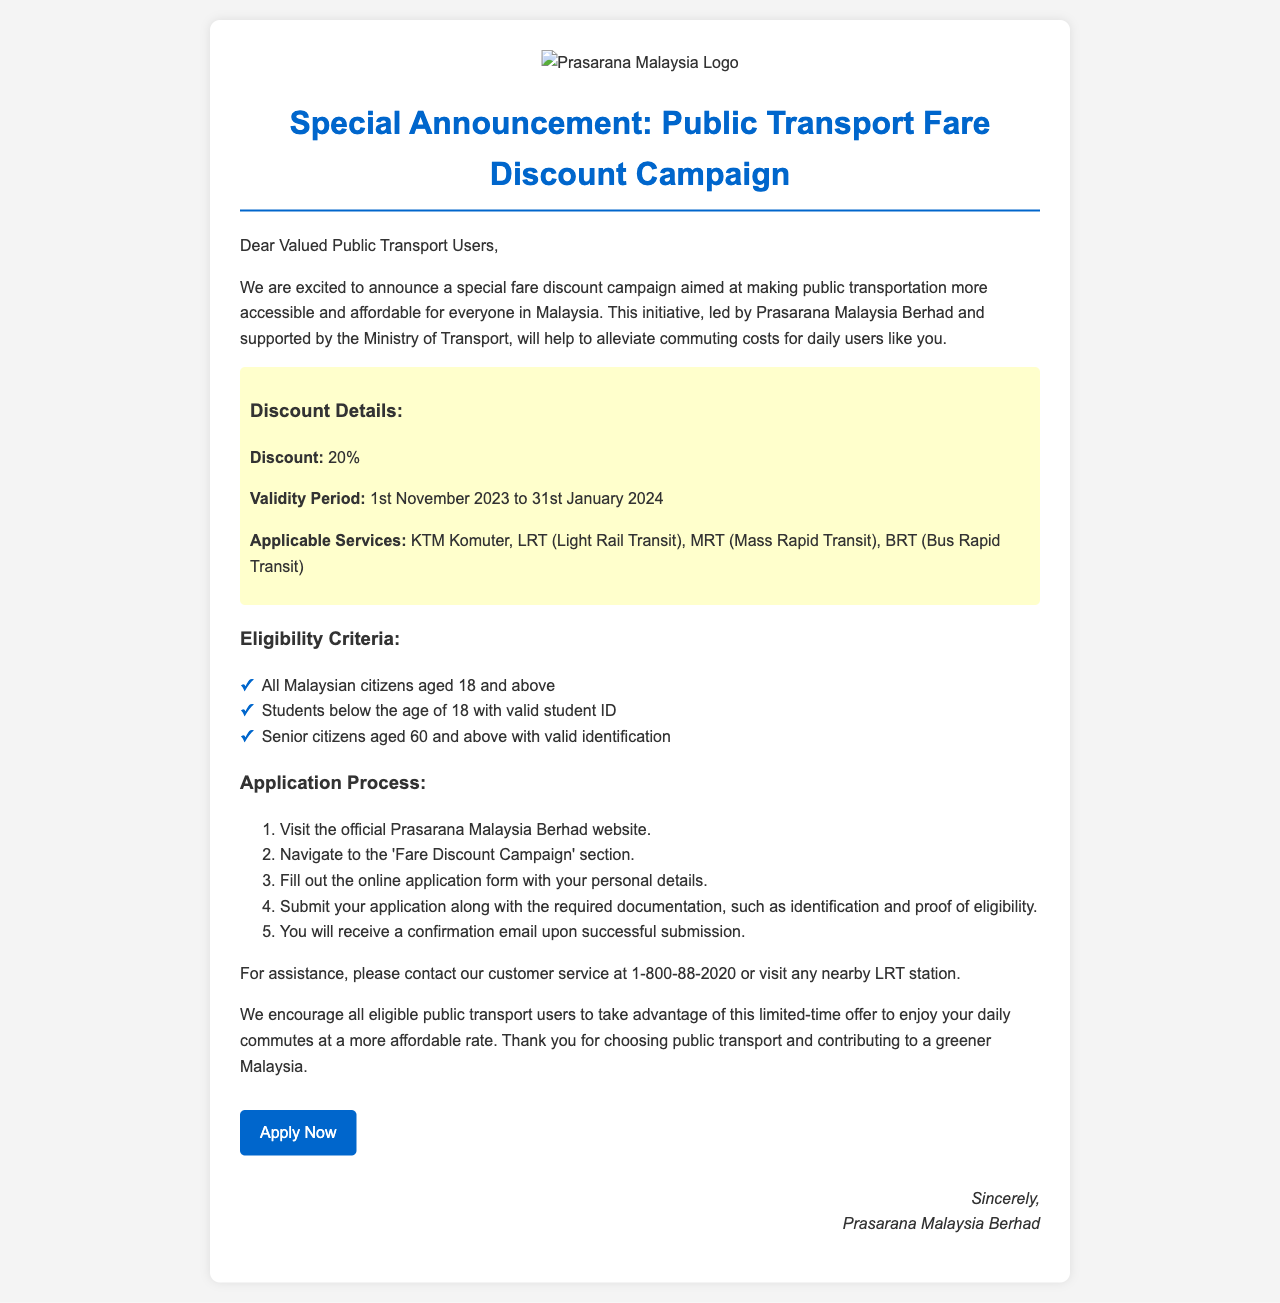what is the discount percentage offered in the campaign? The document states that a 20% discount is being offered.
Answer: 20% what is the validity period of the discount? The document specifies the validity period as "1st November 2023 to 31st January 2024."
Answer: 1st November 2023 to 31st January 2024 who is eligible to apply if they are a student? The eligibility criteria list includes students below the age of 18 with a valid student ID.
Answer: Students below the age of 18 with valid student ID how many steps are in the application process? The document outlines the application process in 5 steps.
Answer: 5 what types of public transport services are included in the discount? The services mentioned include KTM Komuter, LRT, MRT, and BRT.
Answer: KTM Komuter, LRT, MRT, BRT what must be submitted along with the application? The application requires identification and proof of eligibility to be submitted.
Answer: Identification and proof of eligibility who authored the announcement? The document indicates that Prasarana Malaysia Berhad is the author of the announcement.
Answer: Prasarana Malaysia Berhad what contact number is provided for assistance? The document provides a customer service number: 1-800-88-2020.
Answer: 1-800-88-2020 what is the purpose of the fare discount campaign? The document states that the campaign aims to make public transportation more accessible and affordable.
Answer: To make public transportation more accessible and affordable 